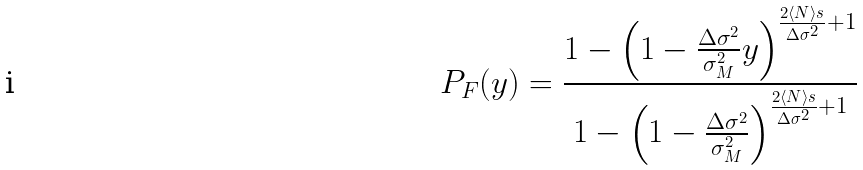Convert formula to latex. <formula><loc_0><loc_0><loc_500><loc_500>P _ { F } ( y ) = \frac { 1 - \left ( 1 - \frac { \Delta \sigma ^ { 2 } } { \sigma ^ { 2 } _ { M } } y \right ) ^ { \frac { 2 \langle N \rangle s } { \Delta \sigma ^ { 2 } } + 1 } } { 1 - \left ( 1 - \frac { \Delta \sigma ^ { 2 } } { \sigma ^ { 2 } _ { M } } \right ) ^ { \frac { 2 \langle N \rangle s } { \Delta \sigma ^ { 2 } } + 1 } }</formula> 